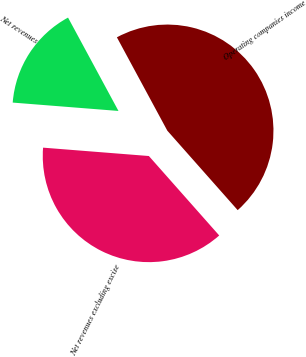Convert chart. <chart><loc_0><loc_0><loc_500><loc_500><pie_chart><fcel>Net revenues<fcel>Net revenues excluding excise<fcel>Operating companies income<nl><fcel>15.86%<fcel>37.79%<fcel>46.35%<nl></chart> 